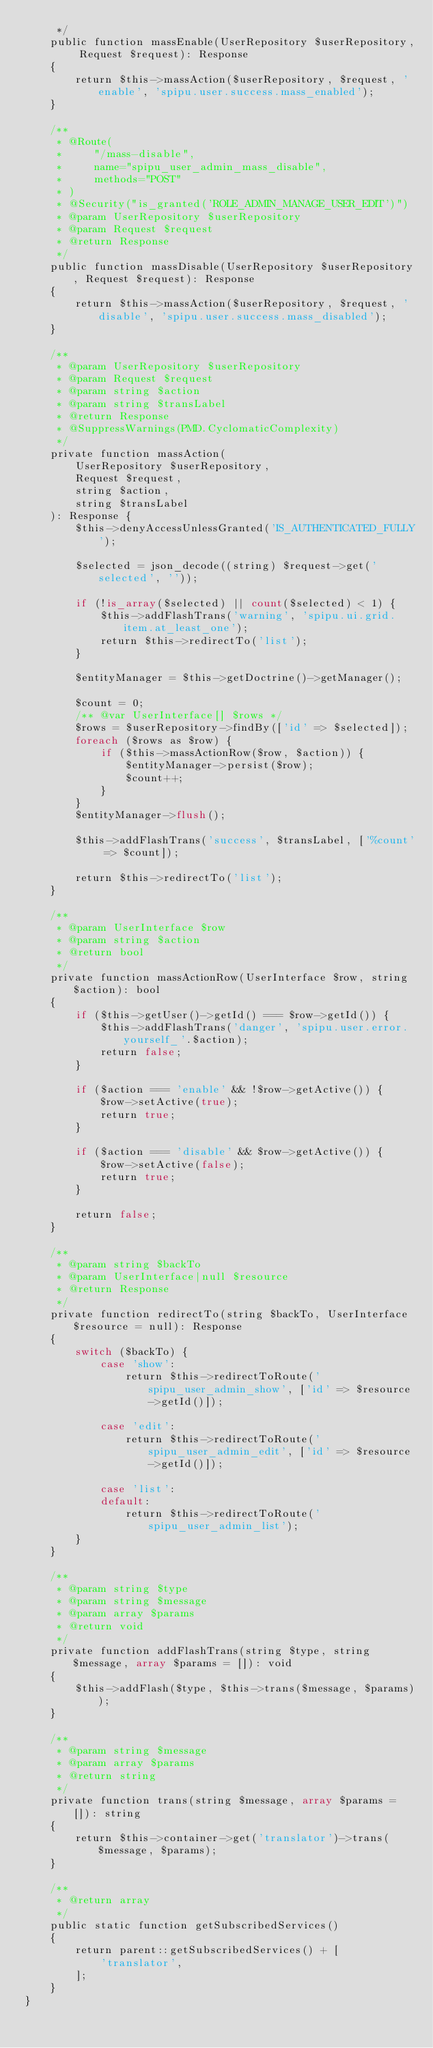<code> <loc_0><loc_0><loc_500><loc_500><_PHP_>     */
    public function massEnable(UserRepository $userRepository, Request $request): Response
    {
        return $this->massAction($userRepository, $request, 'enable', 'spipu.user.success.mass_enabled');
    }

    /**
     * @Route(
     *     "/mass-disable",
     *     name="spipu_user_admin_mass_disable",
     *     methods="POST"
     * )
     * @Security("is_granted('ROLE_ADMIN_MANAGE_USER_EDIT')")
     * @param UserRepository $userRepository
     * @param Request $request
     * @return Response
     */
    public function massDisable(UserRepository $userRepository, Request $request): Response
    {
        return $this->massAction($userRepository, $request, 'disable', 'spipu.user.success.mass_disabled');
    }

    /**
     * @param UserRepository $userRepository
     * @param Request $request
     * @param string $action
     * @param string $transLabel
     * @return Response
     * @SuppressWarnings(PMD.CyclomaticComplexity)
     */
    private function massAction(
        UserRepository $userRepository,
        Request $request,
        string $action,
        string $transLabel
    ): Response {
        $this->denyAccessUnlessGranted('IS_AUTHENTICATED_FULLY');

        $selected = json_decode((string) $request->get('selected', ''));

        if (!is_array($selected) || count($selected) < 1) {
            $this->addFlashTrans('warning', 'spipu.ui.grid.item.at_least_one');
            return $this->redirectTo('list');
        }

        $entityManager = $this->getDoctrine()->getManager();

        $count = 0;
        /** @var UserInterface[] $rows */
        $rows = $userRepository->findBy(['id' => $selected]);
        foreach ($rows as $row) {
            if ($this->massActionRow($row, $action)) {
                $entityManager->persist($row);
                $count++;
            }
        }
        $entityManager->flush();

        $this->addFlashTrans('success', $transLabel, ['%count' => $count]);

        return $this->redirectTo('list');
    }

    /**
     * @param UserInterface $row
     * @param string $action
     * @return bool
     */
    private function massActionRow(UserInterface $row, string $action): bool
    {
        if ($this->getUser()->getId() === $row->getId()) {
            $this->addFlashTrans('danger', 'spipu.user.error.yourself_'.$action);
            return false;
        }

        if ($action === 'enable' && !$row->getActive()) {
            $row->setActive(true);
            return true;
        }

        if ($action === 'disable' && $row->getActive()) {
            $row->setActive(false);
            return true;
        }

        return false;
    }

    /**
     * @param string $backTo
     * @param UserInterface|null $resource
     * @return Response
     */
    private function redirectTo(string $backTo, UserInterface $resource = null): Response
    {
        switch ($backTo) {
            case 'show':
                return $this->redirectToRoute('spipu_user_admin_show', ['id' => $resource->getId()]);

            case 'edit':
                return $this->redirectToRoute('spipu_user_admin_edit', ['id' => $resource->getId()]);

            case 'list':
            default:
                return $this->redirectToRoute('spipu_user_admin_list');
        }
    }

    /**
     * @param string $type
     * @param string $message
     * @param array $params
     * @return void
     */
    private function addFlashTrans(string $type, string $message, array $params = []): void
    {
        $this->addFlash($type, $this->trans($message, $params));
    }

    /**
     * @param string $message
     * @param array $params
     * @return string
     */
    private function trans(string $message, array $params = []): string
    {
        return $this->container->get('translator')->trans($message, $params);
    }

    /**
     * @return array
     */
    public static function getSubscribedServices()
    {
        return parent::getSubscribedServices() + [
            'translator',
        ];
    }
}
</code> 